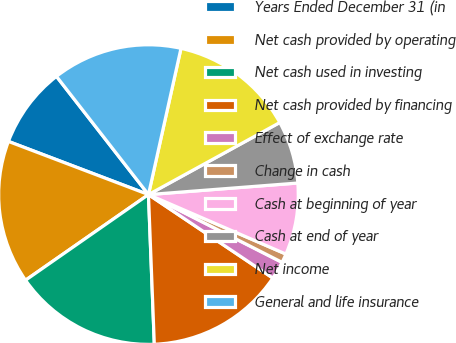Convert chart. <chart><loc_0><loc_0><loc_500><loc_500><pie_chart><fcel>Years Ended December 31 (in<fcel>Net cash provided by operating<fcel>Net cash used in investing<fcel>Net cash provided by financing<fcel>Effect of exchange rate<fcel>Change in cash<fcel>Cash at beginning of year<fcel>Cash at end of year<fcel>Net income<fcel>General and life insurance<nl><fcel>8.7%<fcel>15.46%<fcel>15.94%<fcel>14.97%<fcel>1.94%<fcel>0.97%<fcel>7.73%<fcel>6.76%<fcel>13.53%<fcel>14.01%<nl></chart> 